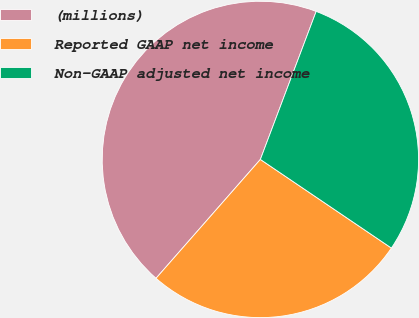<chart> <loc_0><loc_0><loc_500><loc_500><pie_chart><fcel>(millions)<fcel>Reported GAAP net income<fcel>Non-GAAP adjusted net income<nl><fcel>44.27%<fcel>27.0%<fcel>28.73%<nl></chart> 